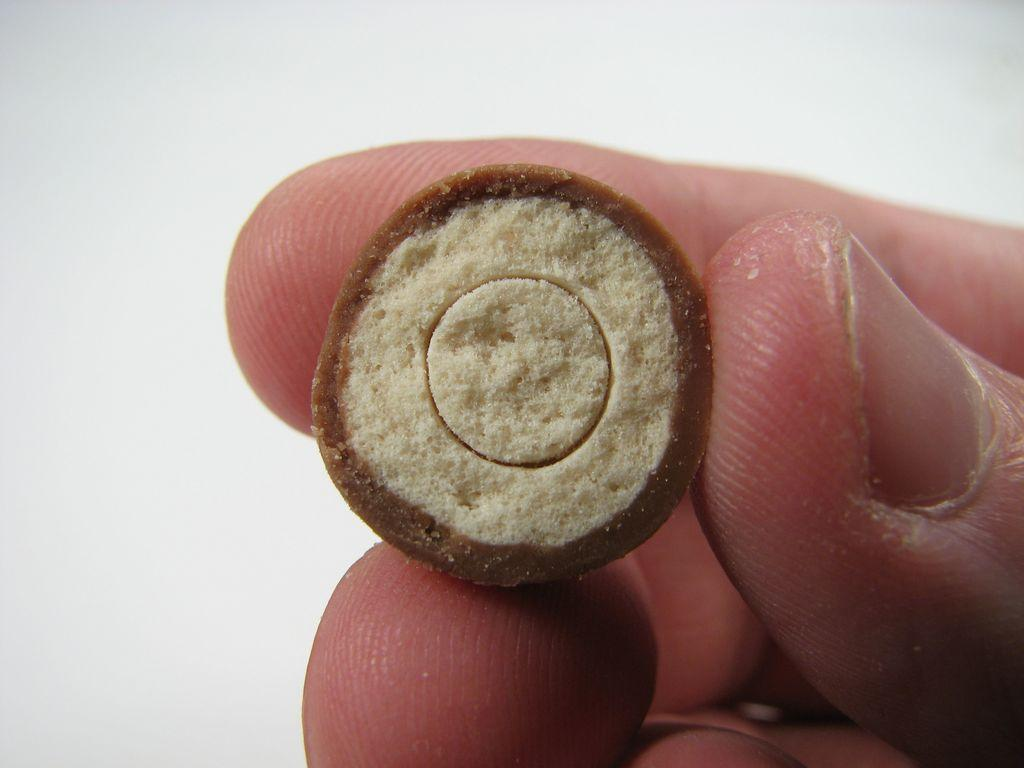What is the person holding in the image? The facts do not specify what the person is holding, only that their fingers are visible. What color is the background of the image? The background of the image is white. What type of canvas is being pulled by the person in the image? There is no canvas or person pulling anything visible in the image. 